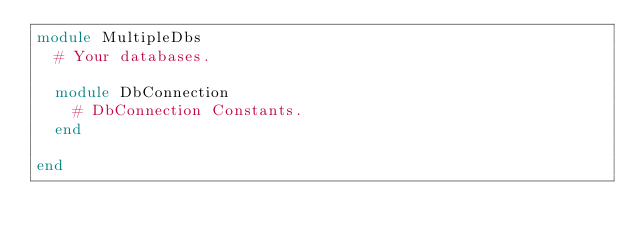<code> <loc_0><loc_0><loc_500><loc_500><_Ruby_>module MultipleDbs
  # Your databases.

  module DbConnection
    # DbConnection Constants.
  end

end
</code> 